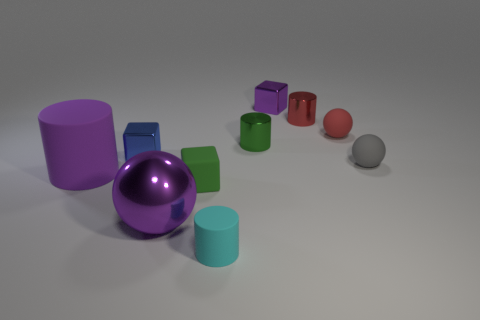How many large objects have the same material as the small red cylinder?
Ensure brevity in your answer.  1. There is a purple metal thing behind the big purple ball; is its shape the same as the large metallic thing?
Offer a very short reply. No. The small metallic thing that is right of the tiny purple cube has what shape?
Keep it short and to the point. Cylinder. There is a rubber thing that is the same color as the metallic ball; what size is it?
Your response must be concise. Large. What is the material of the big ball?
Your response must be concise. Metal. What color is the rubber cylinder that is the same size as the green rubber block?
Make the answer very short. Cyan. What shape is the tiny metallic thing that is the same color as the large cylinder?
Offer a very short reply. Cube. Is the small green shiny object the same shape as the small purple object?
Ensure brevity in your answer.  No. The small object that is both on the right side of the red metallic cylinder and behind the blue shiny block is made of what material?
Make the answer very short. Rubber. The green cube is what size?
Your answer should be compact. Small. 